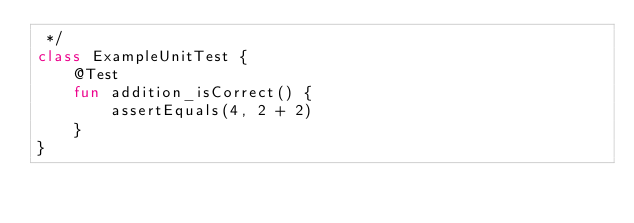Convert code to text. <code><loc_0><loc_0><loc_500><loc_500><_Kotlin_> */
class ExampleUnitTest {
    @Test
    fun addition_isCorrect() {
        assertEquals(4, 2 + 2)
    }
}
</code> 